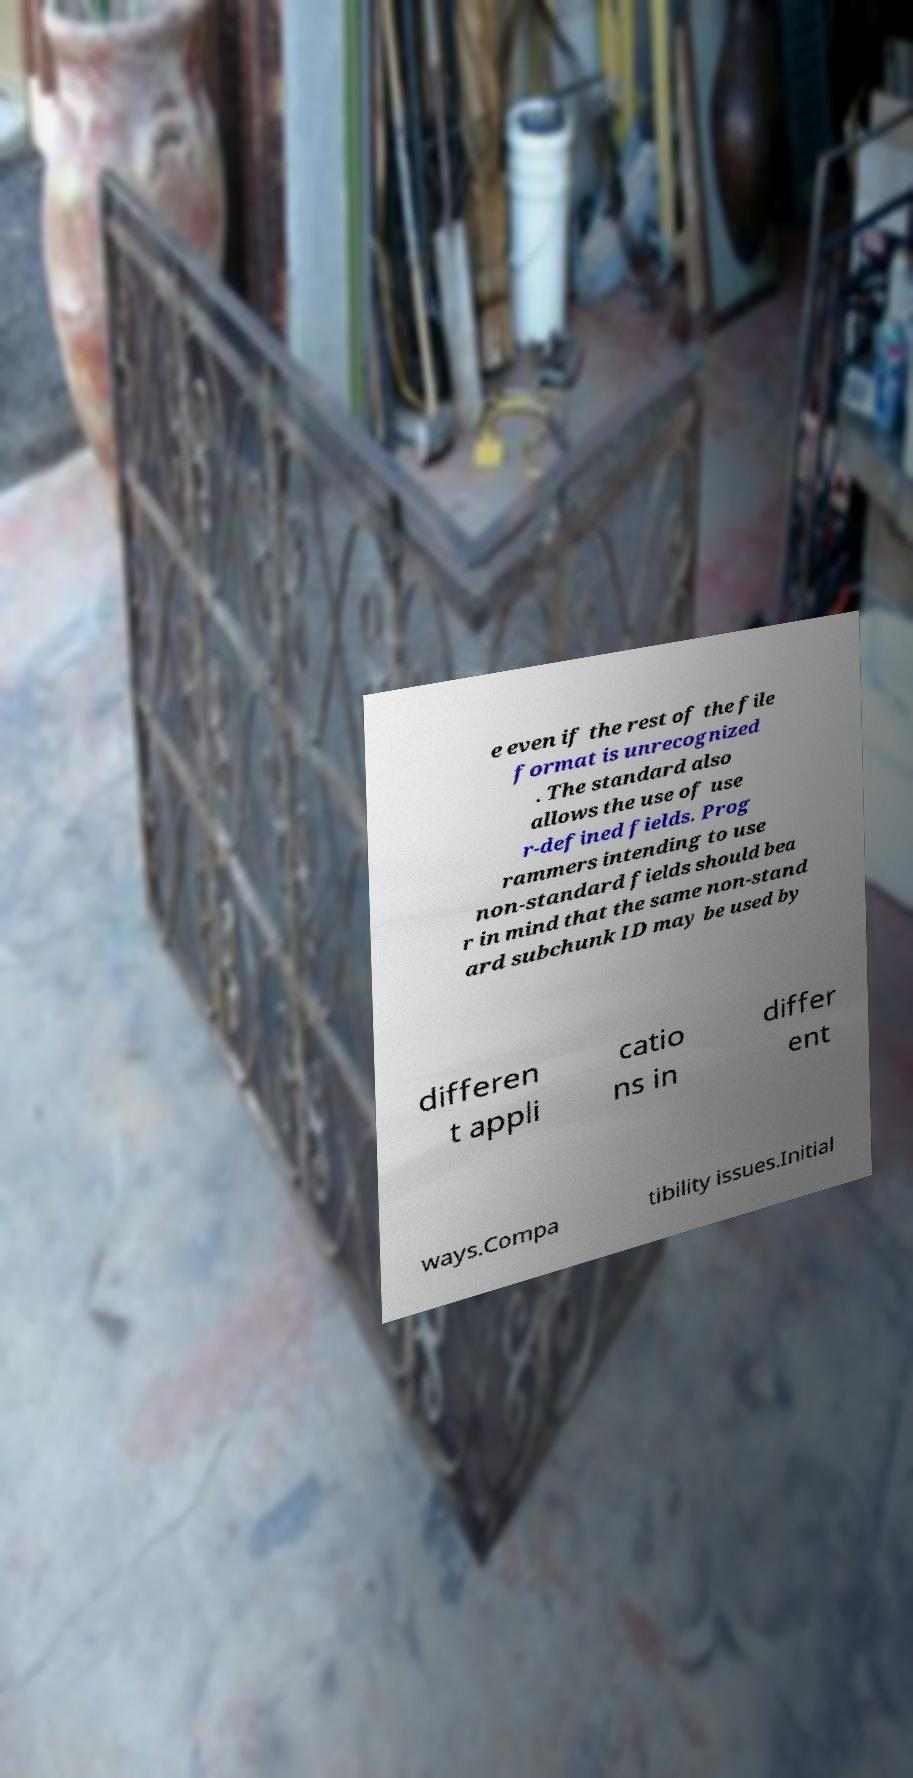Can you accurately transcribe the text from the provided image for me? e even if the rest of the file format is unrecognized . The standard also allows the use of use r-defined fields. Prog rammers intending to use non-standard fields should bea r in mind that the same non-stand ard subchunk ID may be used by differen t appli catio ns in differ ent ways.Compa tibility issues.Initial 